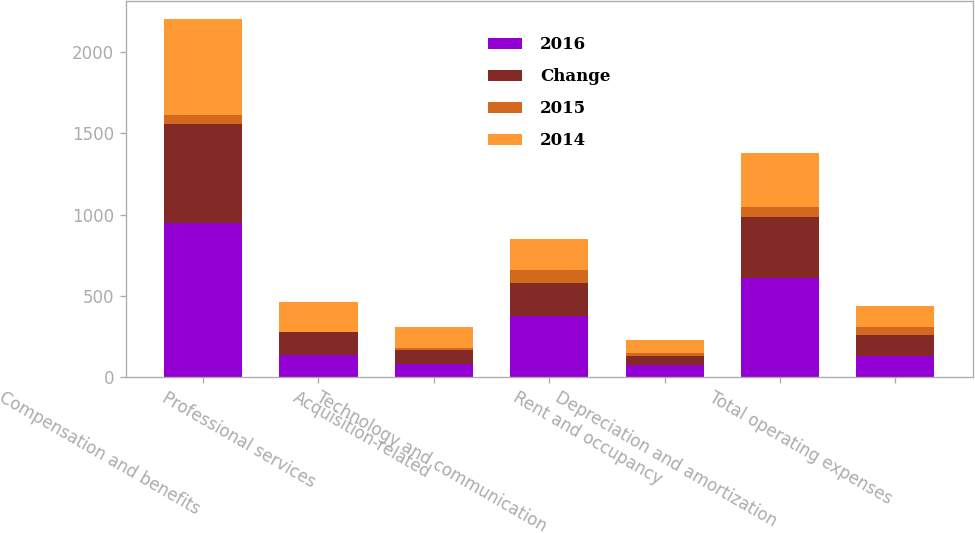<chart> <loc_0><loc_0><loc_500><loc_500><stacked_bar_chart><ecel><fcel>Compensation and benefits<fcel>Professional services<fcel>Acquisition-related<fcel>Technology and communication<fcel>Rent and occupancy<fcel>Depreciation and amortization<fcel>Total operating expenses<nl><fcel>2016<fcel>945<fcel>137<fcel>80<fcel>374<fcel>70<fcel>610<fcel>129<nl><fcel>Change<fcel>611<fcel>139<fcel>88<fcel>203<fcel>57<fcel>374<fcel>129<nl><fcel>2015<fcel>55<fcel>1<fcel>9<fcel>84<fcel>21<fcel>63<fcel>47<nl><fcel>2014<fcel>592<fcel>181<fcel>129<fcel>188<fcel>78<fcel>333<fcel>129<nl></chart> 